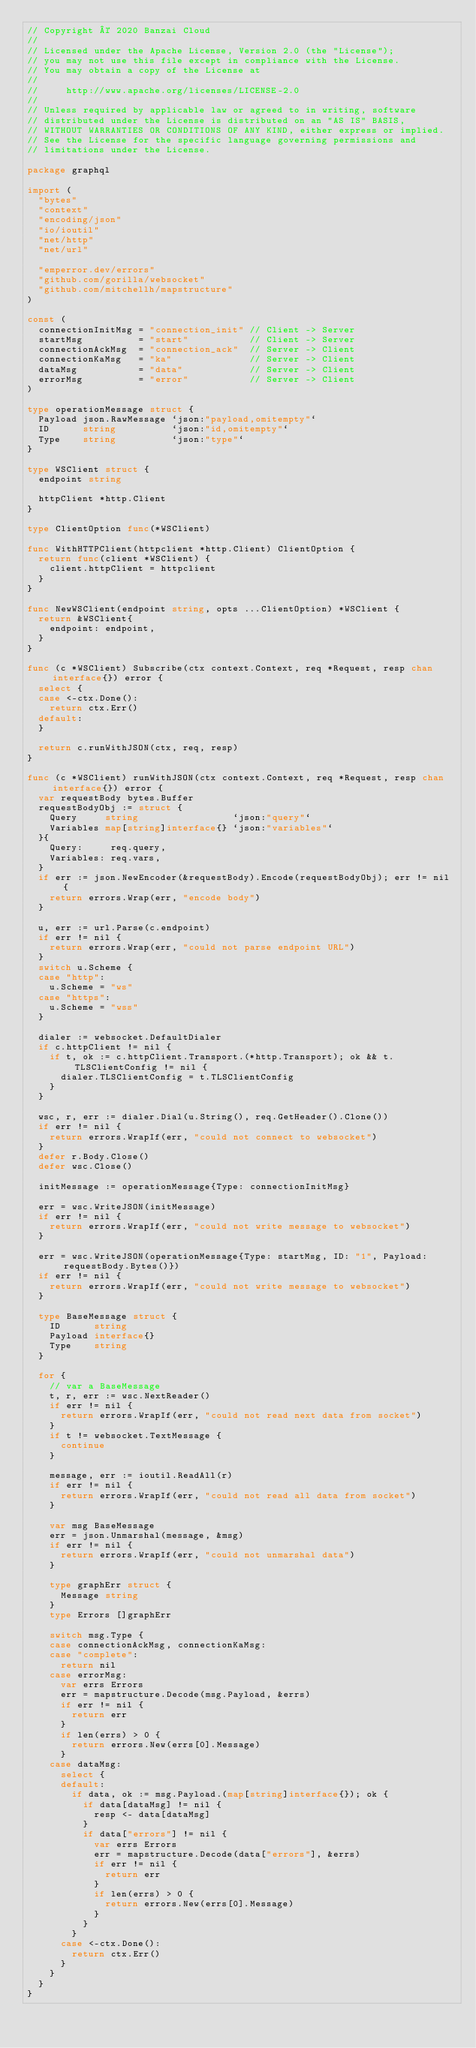<code> <loc_0><loc_0><loc_500><loc_500><_Go_>// Copyright © 2020 Banzai Cloud
//
// Licensed under the Apache License, Version 2.0 (the "License");
// you may not use this file except in compliance with the License.
// You may obtain a copy of the License at
//
//     http://www.apache.org/licenses/LICENSE-2.0
//
// Unless required by applicable law or agreed to in writing, software
// distributed under the License is distributed on an "AS IS" BASIS,
// WITHOUT WARRANTIES OR CONDITIONS OF ANY KIND, either express or implied.
// See the License for the specific language governing permissions and
// limitations under the License.

package graphql

import (
	"bytes"
	"context"
	"encoding/json"
	"io/ioutil"
	"net/http"
	"net/url"

	"emperror.dev/errors"
	"github.com/gorilla/websocket"
	"github.com/mitchellh/mapstructure"
)

const (
	connectionInitMsg = "connection_init" // Client -> Server
	startMsg          = "start"           // Client -> Server
	connectionAckMsg  = "connection_ack"  // Server -> Client
	connectionKaMsg   = "ka"              // Server -> Client
	dataMsg           = "data"            // Server -> Client
	errorMsg          = "error"           // Server -> Client
)

type operationMessage struct {
	Payload json.RawMessage `json:"payload,omitempty"`
	ID      string          `json:"id,omitempty"`
	Type    string          `json:"type"`
}

type WSClient struct {
	endpoint string

	httpClient *http.Client
}

type ClientOption func(*WSClient)

func WithHTTPClient(httpclient *http.Client) ClientOption {
	return func(client *WSClient) {
		client.httpClient = httpclient
	}
}

func NewWSClient(endpoint string, opts ...ClientOption) *WSClient {
	return &WSClient{
		endpoint: endpoint,
	}
}

func (c *WSClient) Subscribe(ctx context.Context, req *Request, resp chan interface{}) error {
	select {
	case <-ctx.Done():
		return ctx.Err()
	default:
	}

	return c.runWithJSON(ctx, req, resp)
}

func (c *WSClient) runWithJSON(ctx context.Context, req *Request, resp chan interface{}) error {
	var requestBody bytes.Buffer
	requestBodyObj := struct {
		Query     string                 `json:"query"`
		Variables map[string]interface{} `json:"variables"`
	}{
		Query:     req.query,
		Variables: req.vars,
	}
	if err := json.NewEncoder(&requestBody).Encode(requestBodyObj); err != nil {
		return errors.Wrap(err, "encode body")
	}

	u, err := url.Parse(c.endpoint)
	if err != nil {
		return errors.Wrap(err, "could not parse endpoint URL")
	}
	switch u.Scheme {
	case "http":
		u.Scheme = "ws"
	case "https":
		u.Scheme = "wss"
	}

	dialer := websocket.DefaultDialer
	if c.httpClient != nil {
		if t, ok := c.httpClient.Transport.(*http.Transport); ok && t.TLSClientConfig != nil {
			dialer.TLSClientConfig = t.TLSClientConfig
		}
	}

	wsc, r, err := dialer.Dial(u.String(), req.GetHeader().Clone())
	if err != nil {
		return errors.WrapIf(err, "could not connect to websocket")
	}
	defer r.Body.Close()
	defer wsc.Close()

	initMessage := operationMessage{Type: connectionInitMsg}

	err = wsc.WriteJSON(initMessage)
	if err != nil {
		return errors.WrapIf(err, "could not write message to websocket")
	}

	err = wsc.WriteJSON(operationMessage{Type: startMsg, ID: "1", Payload: requestBody.Bytes()})
	if err != nil {
		return errors.WrapIf(err, "could not write message to websocket")
	}

	type BaseMessage struct {
		ID      string
		Payload interface{}
		Type    string
	}

	for {
		// var a BaseMessage
		t, r, err := wsc.NextReader()
		if err != nil {
			return errors.WrapIf(err, "could not read next data from socket")
		}
		if t != websocket.TextMessage {
			continue
		}

		message, err := ioutil.ReadAll(r)
		if err != nil {
			return errors.WrapIf(err, "could not read all data from socket")
		}

		var msg BaseMessage
		err = json.Unmarshal(message, &msg)
		if err != nil {
			return errors.WrapIf(err, "could not unmarshal data")
		}

		type graphErr struct {
			Message string
		}
		type Errors []graphErr

		switch msg.Type {
		case connectionAckMsg, connectionKaMsg:
		case "complete":
			return nil
		case errorMsg:
			var errs Errors
			err = mapstructure.Decode(msg.Payload, &errs)
			if err != nil {
				return err
			}
			if len(errs) > 0 {
				return errors.New(errs[0].Message)
			}
		case dataMsg:
			select {
			default:
				if data, ok := msg.Payload.(map[string]interface{}); ok {
					if data[dataMsg] != nil {
						resp <- data[dataMsg]
					}
					if data["errors"] != nil {
						var errs Errors
						err = mapstructure.Decode(data["errors"], &errs)
						if err != nil {
							return err
						}
						if len(errs) > 0 {
							return errors.New(errs[0].Message)
						}
					}
				}
			case <-ctx.Done():
				return ctx.Err()
			}
		}
	}
}
</code> 